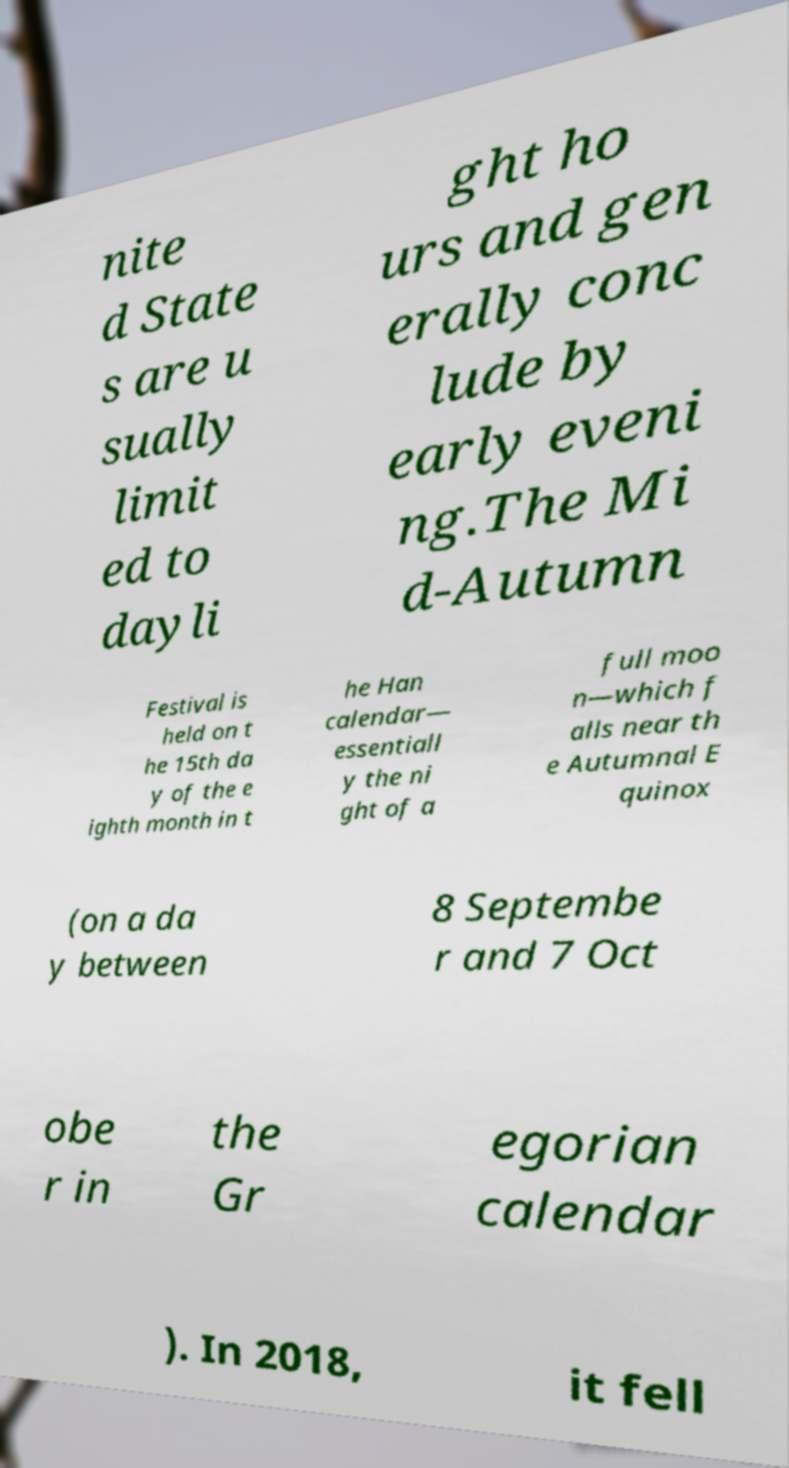Can you read and provide the text displayed in the image?This photo seems to have some interesting text. Can you extract and type it out for me? nite d State s are u sually limit ed to dayli ght ho urs and gen erally conc lude by early eveni ng.The Mi d-Autumn Festival is held on t he 15th da y of the e ighth month in t he Han calendar— essentiall y the ni ght of a full moo n—which f alls near th e Autumnal E quinox (on a da y between 8 Septembe r and 7 Oct obe r in the Gr egorian calendar ). In 2018, it fell 